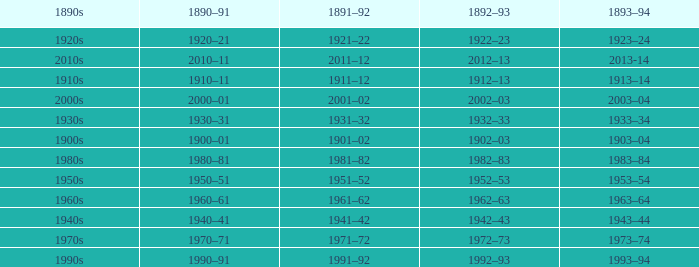What years from 1893-94 that is from the 1890s to the 1990s? 1993–94. 